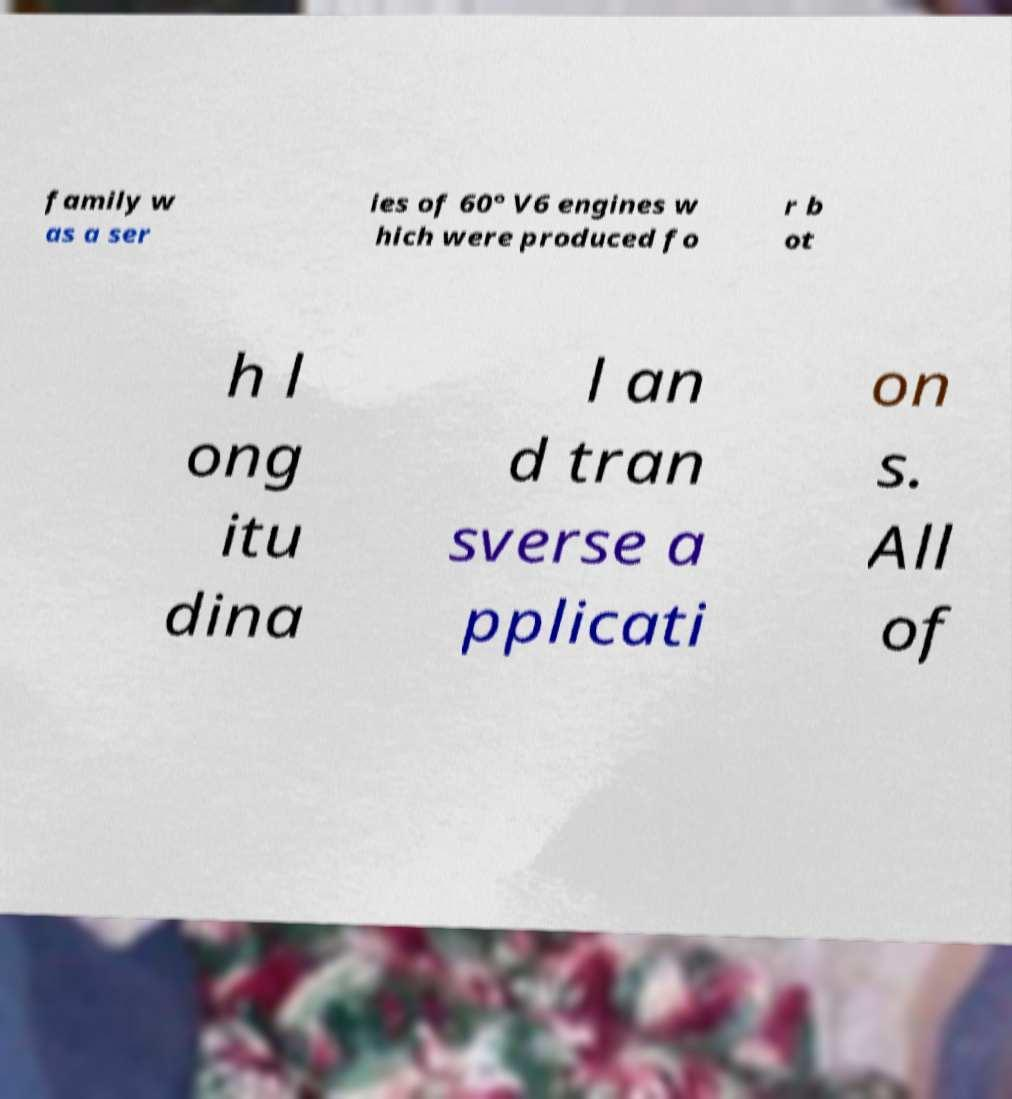Can you read and provide the text displayed in the image?This photo seems to have some interesting text. Can you extract and type it out for me? family w as a ser ies of 60° V6 engines w hich were produced fo r b ot h l ong itu dina l an d tran sverse a pplicati on s. All of 